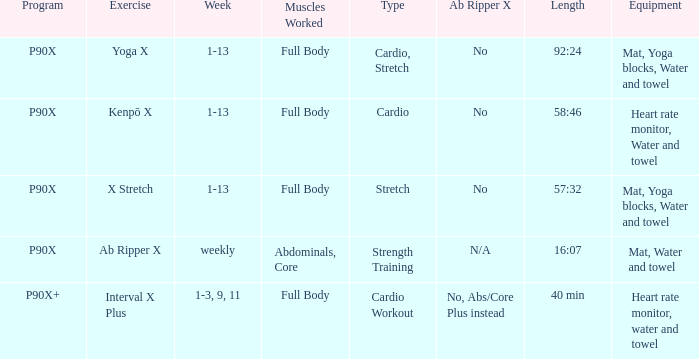What is the training when the devices are heart rate monitor, water, and towel? Kenpō X, Interval X Plus. 